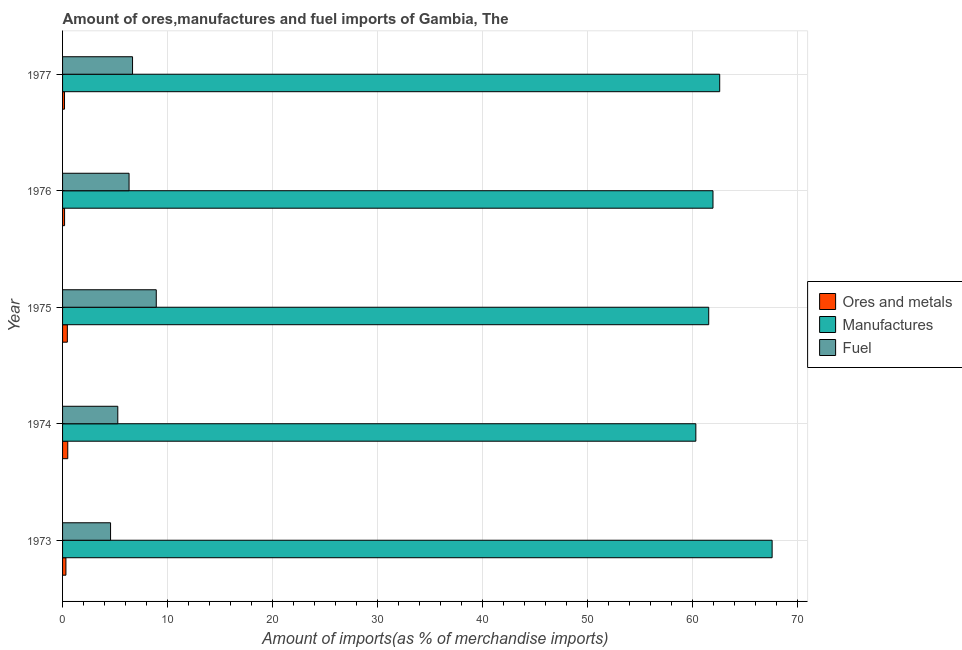How many different coloured bars are there?
Keep it short and to the point. 3. How many groups of bars are there?
Give a very brief answer. 5. Are the number of bars per tick equal to the number of legend labels?
Keep it short and to the point. Yes. In how many cases, is the number of bars for a given year not equal to the number of legend labels?
Your answer should be very brief. 0. What is the percentage of ores and metals imports in 1973?
Your answer should be very brief. 0.32. Across all years, what is the maximum percentage of manufactures imports?
Keep it short and to the point. 67.61. Across all years, what is the minimum percentage of ores and metals imports?
Offer a terse response. 0.19. In which year was the percentage of manufactures imports maximum?
Provide a short and direct response. 1973. In which year was the percentage of ores and metals imports minimum?
Offer a terse response. 1977. What is the total percentage of fuel imports in the graph?
Offer a very short reply. 31.77. What is the difference between the percentage of ores and metals imports in 1973 and that in 1977?
Make the answer very short. 0.13. What is the difference between the percentage of ores and metals imports in 1973 and the percentage of manufactures imports in 1977?
Offer a terse response. -62.29. What is the average percentage of ores and metals imports per year?
Make the answer very short. 0.33. In the year 1976, what is the difference between the percentage of ores and metals imports and percentage of manufactures imports?
Offer a very short reply. -61.78. What is the ratio of the percentage of manufactures imports in 1976 to that in 1977?
Offer a terse response. 0.99. What is the difference between the highest and the second highest percentage of fuel imports?
Offer a very short reply. 2.26. What is the difference between the highest and the lowest percentage of fuel imports?
Give a very brief answer. 4.35. In how many years, is the percentage of ores and metals imports greater than the average percentage of ores and metals imports taken over all years?
Offer a terse response. 2. What does the 1st bar from the top in 1977 represents?
Provide a succinct answer. Fuel. What does the 1st bar from the bottom in 1977 represents?
Keep it short and to the point. Ores and metals. How many bars are there?
Make the answer very short. 15. How many years are there in the graph?
Give a very brief answer. 5. What is the difference between two consecutive major ticks on the X-axis?
Provide a short and direct response. 10. Are the values on the major ticks of X-axis written in scientific E-notation?
Provide a succinct answer. No. Does the graph contain any zero values?
Your response must be concise. No. Where does the legend appear in the graph?
Your answer should be very brief. Center right. How many legend labels are there?
Provide a succinct answer. 3. What is the title of the graph?
Give a very brief answer. Amount of ores,manufactures and fuel imports of Gambia, The. What is the label or title of the X-axis?
Your response must be concise. Amount of imports(as % of merchandise imports). What is the Amount of imports(as % of merchandise imports) of Ores and metals in 1973?
Give a very brief answer. 0.32. What is the Amount of imports(as % of merchandise imports) of Manufactures in 1973?
Your answer should be very brief. 67.61. What is the Amount of imports(as % of merchandise imports) of Fuel in 1973?
Your answer should be very brief. 4.57. What is the Amount of imports(as % of merchandise imports) in Ores and metals in 1974?
Offer a very short reply. 0.5. What is the Amount of imports(as % of merchandise imports) of Manufactures in 1974?
Your answer should be very brief. 60.34. What is the Amount of imports(as % of merchandise imports) of Fuel in 1974?
Provide a short and direct response. 5.26. What is the Amount of imports(as % of merchandise imports) in Ores and metals in 1975?
Keep it short and to the point. 0.46. What is the Amount of imports(as % of merchandise imports) in Manufactures in 1975?
Offer a very short reply. 61.56. What is the Amount of imports(as % of merchandise imports) in Fuel in 1975?
Your answer should be compact. 8.93. What is the Amount of imports(as % of merchandise imports) in Ores and metals in 1976?
Offer a terse response. 0.19. What is the Amount of imports(as % of merchandise imports) in Manufactures in 1976?
Your answer should be compact. 61.97. What is the Amount of imports(as % of merchandise imports) of Fuel in 1976?
Your answer should be very brief. 6.34. What is the Amount of imports(as % of merchandise imports) of Ores and metals in 1977?
Your answer should be compact. 0.19. What is the Amount of imports(as % of merchandise imports) of Manufactures in 1977?
Offer a very short reply. 62.61. What is the Amount of imports(as % of merchandise imports) in Fuel in 1977?
Your response must be concise. 6.67. Across all years, what is the maximum Amount of imports(as % of merchandise imports) of Ores and metals?
Make the answer very short. 0.5. Across all years, what is the maximum Amount of imports(as % of merchandise imports) in Manufactures?
Provide a short and direct response. 67.61. Across all years, what is the maximum Amount of imports(as % of merchandise imports) of Fuel?
Provide a succinct answer. 8.93. Across all years, what is the minimum Amount of imports(as % of merchandise imports) in Ores and metals?
Your answer should be very brief. 0.19. Across all years, what is the minimum Amount of imports(as % of merchandise imports) in Manufactures?
Give a very brief answer. 60.34. Across all years, what is the minimum Amount of imports(as % of merchandise imports) of Fuel?
Provide a short and direct response. 4.57. What is the total Amount of imports(as % of merchandise imports) in Ores and metals in the graph?
Offer a terse response. 1.65. What is the total Amount of imports(as % of merchandise imports) of Manufactures in the graph?
Provide a succinct answer. 314.09. What is the total Amount of imports(as % of merchandise imports) in Fuel in the graph?
Make the answer very short. 31.77. What is the difference between the Amount of imports(as % of merchandise imports) in Ores and metals in 1973 and that in 1974?
Offer a terse response. -0.18. What is the difference between the Amount of imports(as % of merchandise imports) in Manufactures in 1973 and that in 1974?
Ensure brevity in your answer.  7.27. What is the difference between the Amount of imports(as % of merchandise imports) in Fuel in 1973 and that in 1974?
Your answer should be compact. -0.69. What is the difference between the Amount of imports(as % of merchandise imports) of Ores and metals in 1973 and that in 1975?
Make the answer very short. -0.14. What is the difference between the Amount of imports(as % of merchandise imports) in Manufactures in 1973 and that in 1975?
Offer a terse response. 6.04. What is the difference between the Amount of imports(as % of merchandise imports) in Fuel in 1973 and that in 1975?
Give a very brief answer. -4.35. What is the difference between the Amount of imports(as % of merchandise imports) of Ores and metals in 1973 and that in 1976?
Provide a succinct answer. 0.13. What is the difference between the Amount of imports(as % of merchandise imports) of Manufactures in 1973 and that in 1976?
Keep it short and to the point. 5.63. What is the difference between the Amount of imports(as % of merchandise imports) of Fuel in 1973 and that in 1976?
Your response must be concise. -1.76. What is the difference between the Amount of imports(as % of merchandise imports) in Ores and metals in 1973 and that in 1977?
Give a very brief answer. 0.13. What is the difference between the Amount of imports(as % of merchandise imports) in Manufactures in 1973 and that in 1977?
Give a very brief answer. 4.99. What is the difference between the Amount of imports(as % of merchandise imports) in Fuel in 1973 and that in 1977?
Offer a very short reply. -2.09. What is the difference between the Amount of imports(as % of merchandise imports) in Ores and metals in 1974 and that in 1975?
Offer a very short reply. 0.04. What is the difference between the Amount of imports(as % of merchandise imports) in Manufactures in 1974 and that in 1975?
Ensure brevity in your answer.  -1.23. What is the difference between the Amount of imports(as % of merchandise imports) of Fuel in 1974 and that in 1975?
Provide a succinct answer. -3.66. What is the difference between the Amount of imports(as % of merchandise imports) in Ores and metals in 1974 and that in 1976?
Keep it short and to the point. 0.3. What is the difference between the Amount of imports(as % of merchandise imports) in Manufactures in 1974 and that in 1976?
Your answer should be very brief. -1.63. What is the difference between the Amount of imports(as % of merchandise imports) in Fuel in 1974 and that in 1976?
Provide a succinct answer. -1.07. What is the difference between the Amount of imports(as % of merchandise imports) in Ores and metals in 1974 and that in 1977?
Make the answer very short. 0.31. What is the difference between the Amount of imports(as % of merchandise imports) of Manufactures in 1974 and that in 1977?
Your response must be concise. -2.27. What is the difference between the Amount of imports(as % of merchandise imports) of Fuel in 1974 and that in 1977?
Provide a short and direct response. -1.41. What is the difference between the Amount of imports(as % of merchandise imports) of Ores and metals in 1975 and that in 1976?
Give a very brief answer. 0.26. What is the difference between the Amount of imports(as % of merchandise imports) in Manufactures in 1975 and that in 1976?
Ensure brevity in your answer.  -0.41. What is the difference between the Amount of imports(as % of merchandise imports) of Fuel in 1975 and that in 1976?
Keep it short and to the point. 2.59. What is the difference between the Amount of imports(as % of merchandise imports) in Ores and metals in 1975 and that in 1977?
Offer a terse response. 0.27. What is the difference between the Amount of imports(as % of merchandise imports) in Manufactures in 1975 and that in 1977?
Ensure brevity in your answer.  -1.05. What is the difference between the Amount of imports(as % of merchandise imports) in Fuel in 1975 and that in 1977?
Offer a terse response. 2.26. What is the difference between the Amount of imports(as % of merchandise imports) of Ores and metals in 1976 and that in 1977?
Your answer should be very brief. 0.01. What is the difference between the Amount of imports(as % of merchandise imports) in Manufactures in 1976 and that in 1977?
Offer a very short reply. -0.64. What is the difference between the Amount of imports(as % of merchandise imports) in Fuel in 1976 and that in 1977?
Offer a very short reply. -0.33. What is the difference between the Amount of imports(as % of merchandise imports) of Ores and metals in 1973 and the Amount of imports(as % of merchandise imports) of Manufactures in 1974?
Provide a short and direct response. -60.02. What is the difference between the Amount of imports(as % of merchandise imports) of Ores and metals in 1973 and the Amount of imports(as % of merchandise imports) of Fuel in 1974?
Ensure brevity in your answer.  -4.94. What is the difference between the Amount of imports(as % of merchandise imports) of Manufactures in 1973 and the Amount of imports(as % of merchandise imports) of Fuel in 1974?
Provide a short and direct response. 62.34. What is the difference between the Amount of imports(as % of merchandise imports) in Ores and metals in 1973 and the Amount of imports(as % of merchandise imports) in Manufactures in 1975?
Make the answer very short. -61.24. What is the difference between the Amount of imports(as % of merchandise imports) in Ores and metals in 1973 and the Amount of imports(as % of merchandise imports) in Fuel in 1975?
Your response must be concise. -8.61. What is the difference between the Amount of imports(as % of merchandise imports) in Manufactures in 1973 and the Amount of imports(as % of merchandise imports) in Fuel in 1975?
Your answer should be compact. 58.68. What is the difference between the Amount of imports(as % of merchandise imports) of Ores and metals in 1973 and the Amount of imports(as % of merchandise imports) of Manufactures in 1976?
Offer a very short reply. -61.65. What is the difference between the Amount of imports(as % of merchandise imports) in Ores and metals in 1973 and the Amount of imports(as % of merchandise imports) in Fuel in 1976?
Keep it short and to the point. -6.02. What is the difference between the Amount of imports(as % of merchandise imports) of Manufactures in 1973 and the Amount of imports(as % of merchandise imports) of Fuel in 1976?
Provide a short and direct response. 61.27. What is the difference between the Amount of imports(as % of merchandise imports) of Ores and metals in 1973 and the Amount of imports(as % of merchandise imports) of Manufactures in 1977?
Make the answer very short. -62.29. What is the difference between the Amount of imports(as % of merchandise imports) of Ores and metals in 1973 and the Amount of imports(as % of merchandise imports) of Fuel in 1977?
Make the answer very short. -6.35. What is the difference between the Amount of imports(as % of merchandise imports) in Manufactures in 1973 and the Amount of imports(as % of merchandise imports) in Fuel in 1977?
Your answer should be compact. 60.94. What is the difference between the Amount of imports(as % of merchandise imports) in Ores and metals in 1974 and the Amount of imports(as % of merchandise imports) in Manufactures in 1975?
Ensure brevity in your answer.  -61.07. What is the difference between the Amount of imports(as % of merchandise imports) of Ores and metals in 1974 and the Amount of imports(as % of merchandise imports) of Fuel in 1975?
Your answer should be very brief. -8.43. What is the difference between the Amount of imports(as % of merchandise imports) in Manufactures in 1974 and the Amount of imports(as % of merchandise imports) in Fuel in 1975?
Provide a short and direct response. 51.41. What is the difference between the Amount of imports(as % of merchandise imports) in Ores and metals in 1974 and the Amount of imports(as % of merchandise imports) in Manufactures in 1976?
Ensure brevity in your answer.  -61.48. What is the difference between the Amount of imports(as % of merchandise imports) of Ores and metals in 1974 and the Amount of imports(as % of merchandise imports) of Fuel in 1976?
Your response must be concise. -5.84. What is the difference between the Amount of imports(as % of merchandise imports) of Manufactures in 1974 and the Amount of imports(as % of merchandise imports) of Fuel in 1976?
Your answer should be compact. 54. What is the difference between the Amount of imports(as % of merchandise imports) in Ores and metals in 1974 and the Amount of imports(as % of merchandise imports) in Manufactures in 1977?
Keep it short and to the point. -62.12. What is the difference between the Amount of imports(as % of merchandise imports) in Ores and metals in 1974 and the Amount of imports(as % of merchandise imports) in Fuel in 1977?
Offer a terse response. -6.17. What is the difference between the Amount of imports(as % of merchandise imports) of Manufactures in 1974 and the Amount of imports(as % of merchandise imports) of Fuel in 1977?
Provide a succinct answer. 53.67. What is the difference between the Amount of imports(as % of merchandise imports) in Ores and metals in 1975 and the Amount of imports(as % of merchandise imports) in Manufactures in 1976?
Give a very brief answer. -61.52. What is the difference between the Amount of imports(as % of merchandise imports) of Ores and metals in 1975 and the Amount of imports(as % of merchandise imports) of Fuel in 1976?
Keep it short and to the point. -5.88. What is the difference between the Amount of imports(as % of merchandise imports) in Manufactures in 1975 and the Amount of imports(as % of merchandise imports) in Fuel in 1976?
Offer a very short reply. 55.23. What is the difference between the Amount of imports(as % of merchandise imports) of Ores and metals in 1975 and the Amount of imports(as % of merchandise imports) of Manufactures in 1977?
Ensure brevity in your answer.  -62.16. What is the difference between the Amount of imports(as % of merchandise imports) in Ores and metals in 1975 and the Amount of imports(as % of merchandise imports) in Fuel in 1977?
Your answer should be very brief. -6.21. What is the difference between the Amount of imports(as % of merchandise imports) of Manufactures in 1975 and the Amount of imports(as % of merchandise imports) of Fuel in 1977?
Provide a succinct answer. 54.9. What is the difference between the Amount of imports(as % of merchandise imports) of Ores and metals in 1976 and the Amount of imports(as % of merchandise imports) of Manufactures in 1977?
Offer a very short reply. -62.42. What is the difference between the Amount of imports(as % of merchandise imports) in Ores and metals in 1976 and the Amount of imports(as % of merchandise imports) in Fuel in 1977?
Your answer should be very brief. -6.48. What is the difference between the Amount of imports(as % of merchandise imports) in Manufactures in 1976 and the Amount of imports(as % of merchandise imports) in Fuel in 1977?
Your answer should be very brief. 55.3. What is the average Amount of imports(as % of merchandise imports) in Ores and metals per year?
Provide a short and direct response. 0.33. What is the average Amount of imports(as % of merchandise imports) of Manufactures per year?
Your response must be concise. 62.82. What is the average Amount of imports(as % of merchandise imports) in Fuel per year?
Your response must be concise. 6.35. In the year 1973, what is the difference between the Amount of imports(as % of merchandise imports) of Ores and metals and Amount of imports(as % of merchandise imports) of Manufactures?
Provide a short and direct response. -67.29. In the year 1973, what is the difference between the Amount of imports(as % of merchandise imports) in Ores and metals and Amount of imports(as % of merchandise imports) in Fuel?
Keep it short and to the point. -4.25. In the year 1973, what is the difference between the Amount of imports(as % of merchandise imports) in Manufactures and Amount of imports(as % of merchandise imports) in Fuel?
Give a very brief answer. 63.03. In the year 1974, what is the difference between the Amount of imports(as % of merchandise imports) in Ores and metals and Amount of imports(as % of merchandise imports) in Manufactures?
Your answer should be compact. -59.84. In the year 1974, what is the difference between the Amount of imports(as % of merchandise imports) in Ores and metals and Amount of imports(as % of merchandise imports) in Fuel?
Your answer should be very brief. -4.77. In the year 1974, what is the difference between the Amount of imports(as % of merchandise imports) in Manufactures and Amount of imports(as % of merchandise imports) in Fuel?
Ensure brevity in your answer.  55.07. In the year 1975, what is the difference between the Amount of imports(as % of merchandise imports) in Ores and metals and Amount of imports(as % of merchandise imports) in Manufactures?
Provide a succinct answer. -61.11. In the year 1975, what is the difference between the Amount of imports(as % of merchandise imports) in Ores and metals and Amount of imports(as % of merchandise imports) in Fuel?
Give a very brief answer. -8.47. In the year 1975, what is the difference between the Amount of imports(as % of merchandise imports) in Manufactures and Amount of imports(as % of merchandise imports) in Fuel?
Make the answer very short. 52.64. In the year 1976, what is the difference between the Amount of imports(as % of merchandise imports) in Ores and metals and Amount of imports(as % of merchandise imports) in Manufactures?
Provide a succinct answer. -61.78. In the year 1976, what is the difference between the Amount of imports(as % of merchandise imports) of Ores and metals and Amount of imports(as % of merchandise imports) of Fuel?
Ensure brevity in your answer.  -6.14. In the year 1976, what is the difference between the Amount of imports(as % of merchandise imports) in Manufactures and Amount of imports(as % of merchandise imports) in Fuel?
Provide a succinct answer. 55.64. In the year 1977, what is the difference between the Amount of imports(as % of merchandise imports) of Ores and metals and Amount of imports(as % of merchandise imports) of Manufactures?
Make the answer very short. -62.43. In the year 1977, what is the difference between the Amount of imports(as % of merchandise imports) of Ores and metals and Amount of imports(as % of merchandise imports) of Fuel?
Offer a very short reply. -6.48. In the year 1977, what is the difference between the Amount of imports(as % of merchandise imports) of Manufactures and Amount of imports(as % of merchandise imports) of Fuel?
Provide a short and direct response. 55.94. What is the ratio of the Amount of imports(as % of merchandise imports) of Ores and metals in 1973 to that in 1974?
Give a very brief answer. 0.65. What is the ratio of the Amount of imports(as % of merchandise imports) of Manufactures in 1973 to that in 1974?
Your answer should be compact. 1.12. What is the ratio of the Amount of imports(as % of merchandise imports) in Fuel in 1973 to that in 1974?
Your answer should be compact. 0.87. What is the ratio of the Amount of imports(as % of merchandise imports) of Ores and metals in 1973 to that in 1975?
Ensure brevity in your answer.  0.7. What is the ratio of the Amount of imports(as % of merchandise imports) of Manufactures in 1973 to that in 1975?
Your answer should be very brief. 1.1. What is the ratio of the Amount of imports(as % of merchandise imports) in Fuel in 1973 to that in 1975?
Your answer should be very brief. 0.51. What is the ratio of the Amount of imports(as % of merchandise imports) in Ores and metals in 1973 to that in 1976?
Give a very brief answer. 1.66. What is the ratio of the Amount of imports(as % of merchandise imports) of Manufactures in 1973 to that in 1976?
Offer a terse response. 1.09. What is the ratio of the Amount of imports(as % of merchandise imports) of Fuel in 1973 to that in 1976?
Keep it short and to the point. 0.72. What is the ratio of the Amount of imports(as % of merchandise imports) of Ores and metals in 1973 to that in 1977?
Provide a short and direct response. 1.72. What is the ratio of the Amount of imports(as % of merchandise imports) of Manufactures in 1973 to that in 1977?
Your answer should be very brief. 1.08. What is the ratio of the Amount of imports(as % of merchandise imports) in Fuel in 1973 to that in 1977?
Provide a short and direct response. 0.69. What is the ratio of the Amount of imports(as % of merchandise imports) in Ores and metals in 1974 to that in 1975?
Make the answer very short. 1.09. What is the ratio of the Amount of imports(as % of merchandise imports) of Manufactures in 1974 to that in 1975?
Offer a very short reply. 0.98. What is the ratio of the Amount of imports(as % of merchandise imports) in Fuel in 1974 to that in 1975?
Keep it short and to the point. 0.59. What is the ratio of the Amount of imports(as % of merchandise imports) of Ores and metals in 1974 to that in 1976?
Offer a very short reply. 2.58. What is the ratio of the Amount of imports(as % of merchandise imports) of Manufactures in 1974 to that in 1976?
Offer a very short reply. 0.97. What is the ratio of the Amount of imports(as % of merchandise imports) in Fuel in 1974 to that in 1976?
Your answer should be compact. 0.83. What is the ratio of the Amount of imports(as % of merchandise imports) of Ores and metals in 1974 to that in 1977?
Make the answer very short. 2.67. What is the ratio of the Amount of imports(as % of merchandise imports) of Manufactures in 1974 to that in 1977?
Provide a short and direct response. 0.96. What is the ratio of the Amount of imports(as % of merchandise imports) in Fuel in 1974 to that in 1977?
Provide a short and direct response. 0.79. What is the ratio of the Amount of imports(as % of merchandise imports) of Ores and metals in 1975 to that in 1976?
Your answer should be compact. 2.37. What is the ratio of the Amount of imports(as % of merchandise imports) in Fuel in 1975 to that in 1976?
Make the answer very short. 1.41. What is the ratio of the Amount of imports(as % of merchandise imports) of Ores and metals in 1975 to that in 1977?
Make the answer very short. 2.45. What is the ratio of the Amount of imports(as % of merchandise imports) in Manufactures in 1975 to that in 1977?
Offer a very short reply. 0.98. What is the ratio of the Amount of imports(as % of merchandise imports) in Fuel in 1975 to that in 1977?
Provide a short and direct response. 1.34. What is the ratio of the Amount of imports(as % of merchandise imports) of Ores and metals in 1976 to that in 1977?
Your response must be concise. 1.03. What is the ratio of the Amount of imports(as % of merchandise imports) of Fuel in 1976 to that in 1977?
Make the answer very short. 0.95. What is the difference between the highest and the second highest Amount of imports(as % of merchandise imports) of Ores and metals?
Keep it short and to the point. 0.04. What is the difference between the highest and the second highest Amount of imports(as % of merchandise imports) in Manufactures?
Keep it short and to the point. 4.99. What is the difference between the highest and the second highest Amount of imports(as % of merchandise imports) in Fuel?
Give a very brief answer. 2.26. What is the difference between the highest and the lowest Amount of imports(as % of merchandise imports) in Ores and metals?
Offer a very short reply. 0.31. What is the difference between the highest and the lowest Amount of imports(as % of merchandise imports) of Manufactures?
Ensure brevity in your answer.  7.27. What is the difference between the highest and the lowest Amount of imports(as % of merchandise imports) of Fuel?
Offer a very short reply. 4.35. 